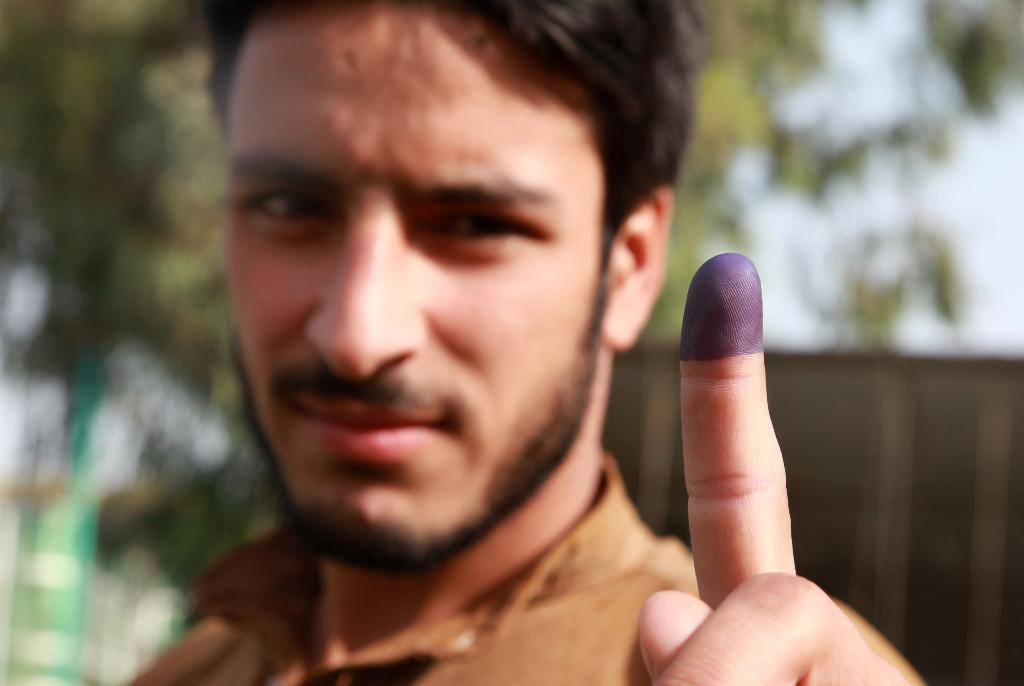Who or what is the main subject in the image? There is a person in the image. What is the person wearing? The person is wearing a brown shirt. What can be seen in the background of the image? There are trees in the background of the image. What is the color of the trees? The trees are green. What else is visible in the image? The sky is visible in the image. What is the color of the sky? The sky is white. Reasoning: Let' Let's think step by step in order to produce the conversation. We start by identifying the main subject in the image, which is the person. Then, we describe the person's clothing, focusing on the brown shirt. Next, we mention the background of the image, which includes green trees. We then describe the sky, noting that it is white. Each question is designed to elicit a specific detail about the image that is known from the provided facts. Absurd Question/Answer: How many snakes are wrapped around the person's neck in the image? There are no snakes present in the image. What type of rings can be seen on the person's fingers in the image? There are no rings visible on the person's fingers in the image. 